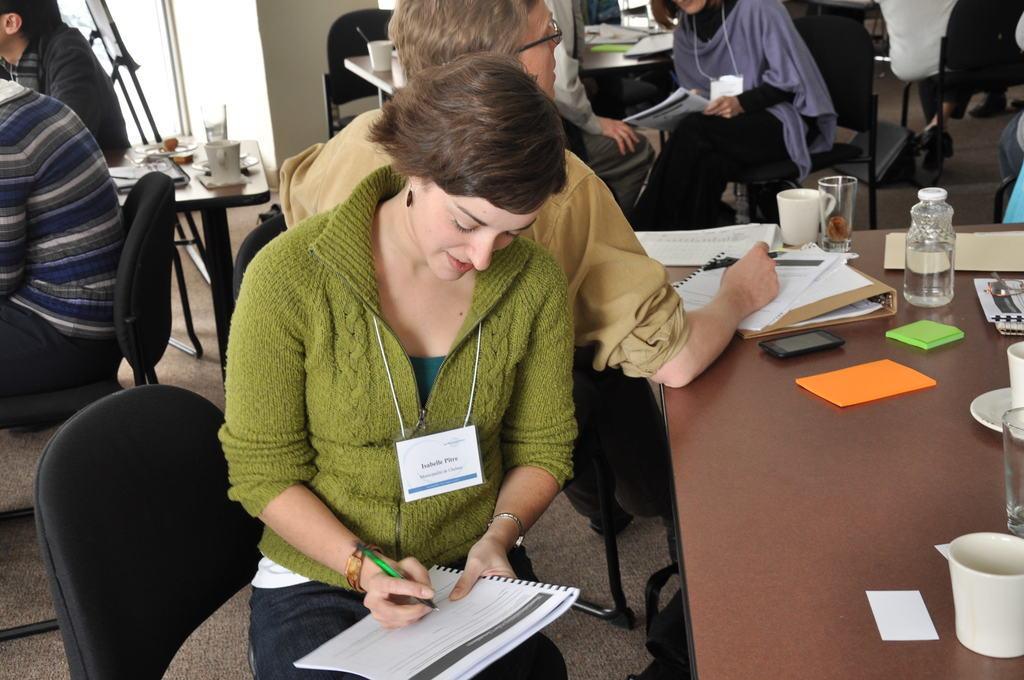Describe this image in one or two sentences. This image is taken inside a room, there are few people in this room. In the middle of the image a woman is sitting on the chair and writing on the book. In the right side of the image there is a table and there are many things on it. In the left side of the image a man is sitting on the chair. At the background there are many people sitting and discussing. There is a wall. 